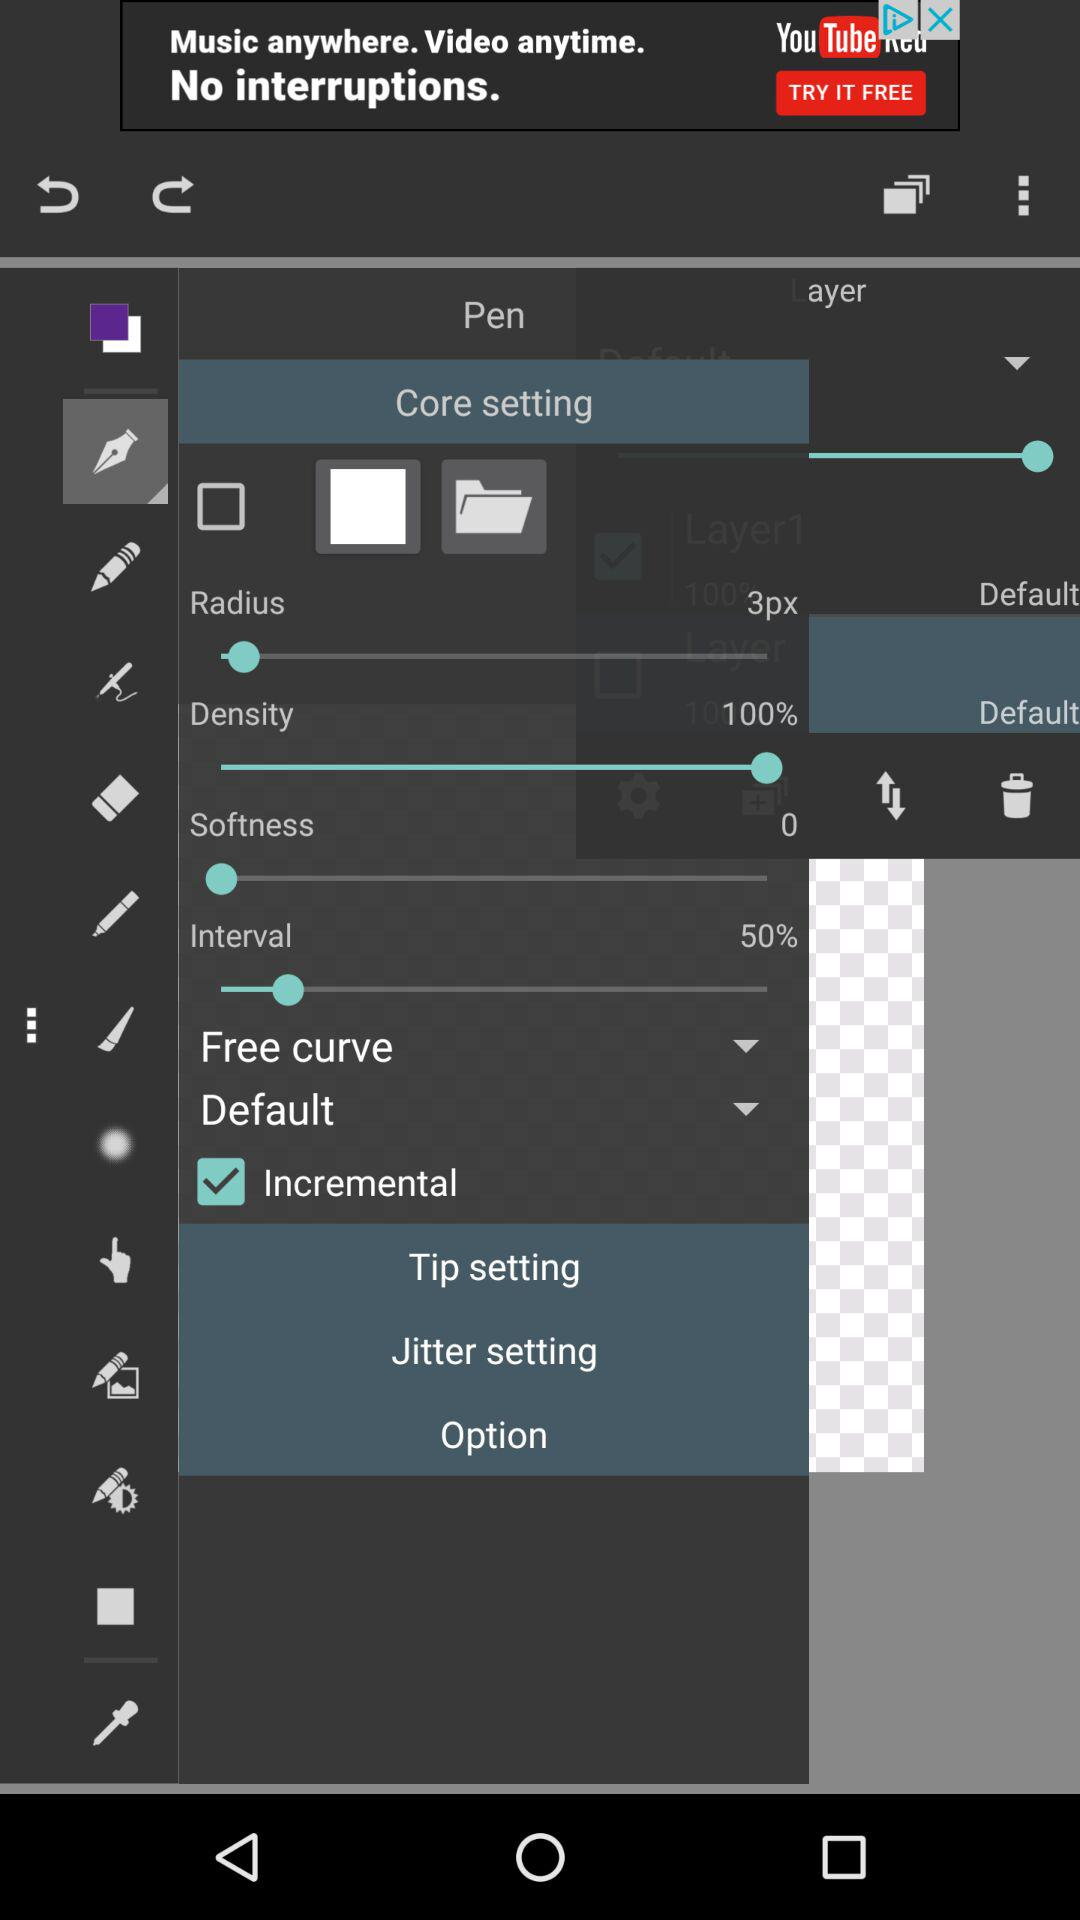What is the setting for radius? The radius is set to 3px. 